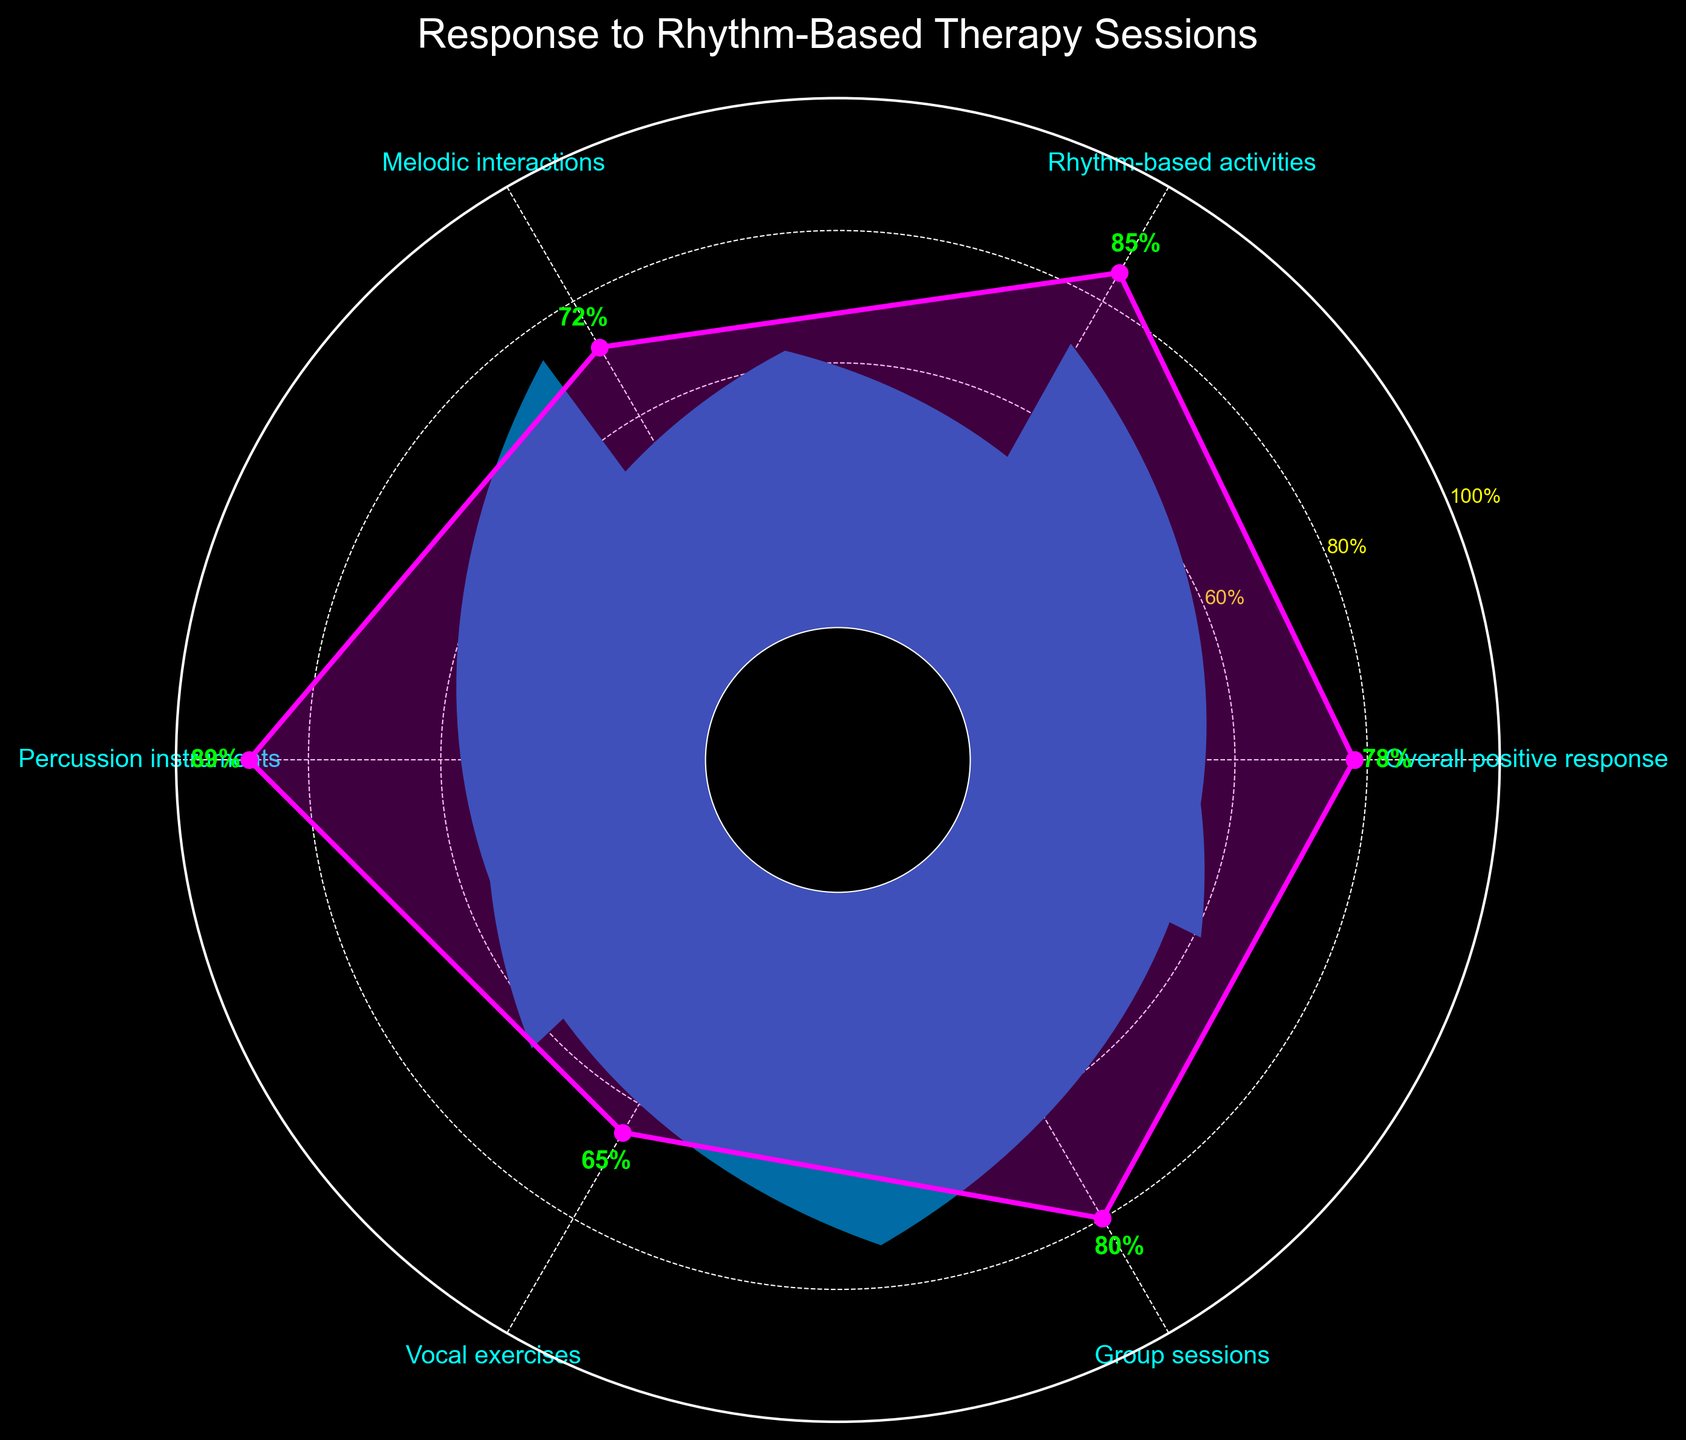Which therapy session category has the highest percentage of positive response? Locate the category with the highest percentage in the figure. The highest percentage listed is for "Percussion instruments" which is 89%.
Answer: Percussion instruments What is the title of the chart? The title is usually placed at the top of the chart. Here, it reads "Response to Rhythm-Based Therapy Sessions".
Answer: Response to Rhythm-Based Therapy Sessions How does the positive response for "Melodic interactions" compare with "Vocal exercises"? Check the percentages for both categories. "Melodic interactions" has 72% and "Vocal exercises" has 65%. Compare these values.
Answer: Melodic interactions is higher What is the percentage difference between "Group sessions" and "Vocal exercises"? "Group sessions" is 80% and "Vocal exercises" is 65%. Subtract 65% from 80% to find the difference.
Answer: 15% Which category has the lowest percentage of positive response? Skim through the percentages and identify the lowest one. The lowest is "Vocal exercises" with 65%.
Answer: Vocal exercises What is the percentage of positive responses in rhythm-based activities? Locate the section labeled "Rhythm-based activities" and read the associated percentage, which is 85%.
Answer: 85% What is the average positive response rate across all categories? Sum all percentages (78 + 85 + 72 + 89 + 65 + 80) and divide by the number of categories (6): (78 + 85 + 72 + 89 + 65 + 80) / 6
Answer: 78.17% Is the percentage of positive response in "Percussion instruments" more than in "Overall positive response"? Compare the percentages for "Percussion instruments" (89%) and "Overall positive response" (78%).
Answer: Yes How many therapy categories are displayed in the chart? Count the number of distinct therapy categories listed around the chart. There are six categories.
Answer: Six What is the range of the percentages shown in the chart? Identify the highest (89%) and lowest (65%) values and calculate the range (89% - 65%).
Answer: 24% 